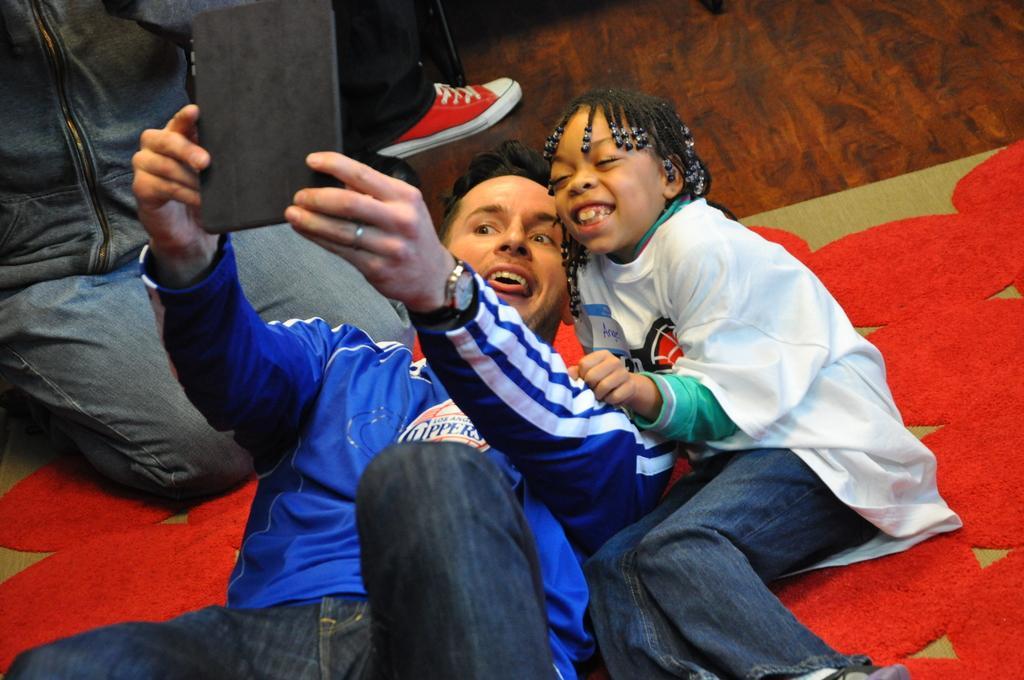Please provide a concise description of this image. There are people and this girl smiling, beside her there is a man holding a gadget. We can see mat on the floor. 